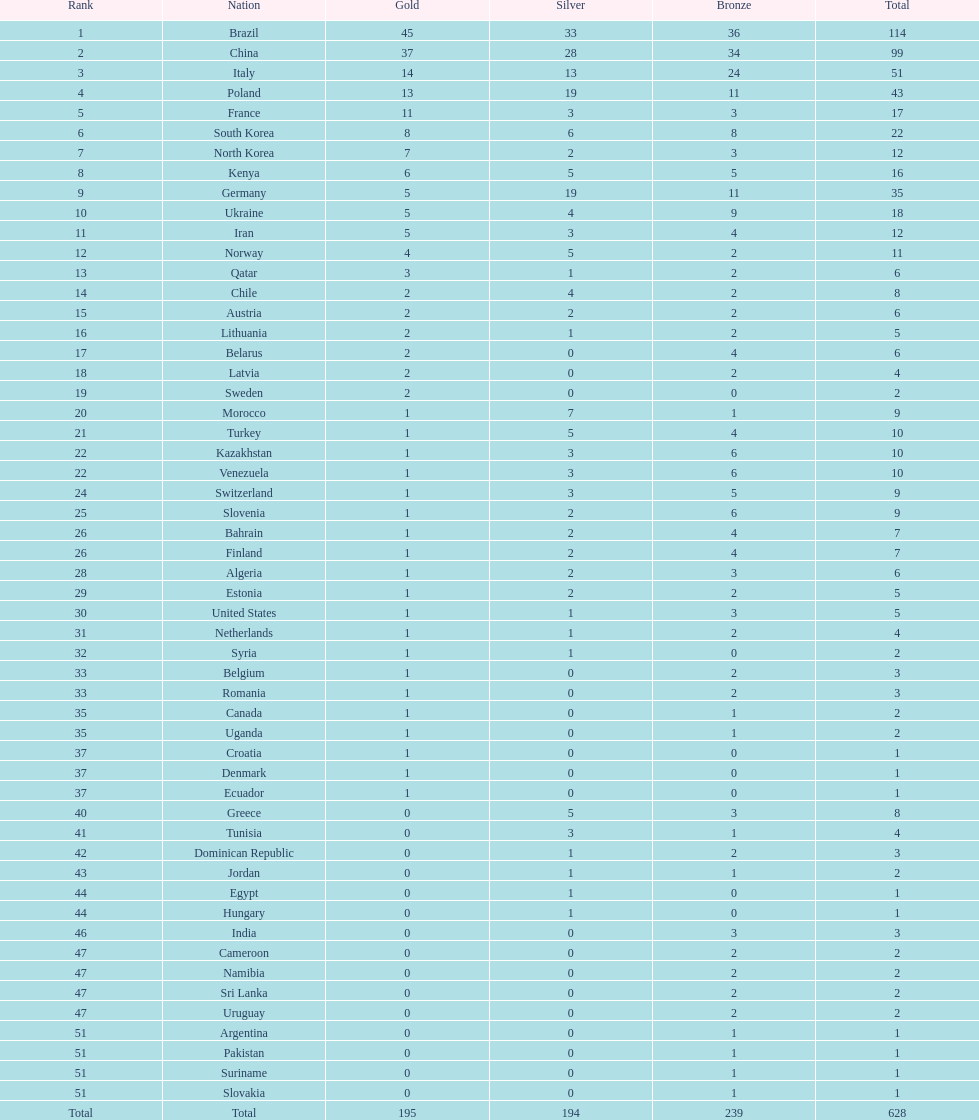What's the total count of gold medals secured by germany? 5. Can you give me this table as a dict? {'header': ['Rank', 'Nation', 'Gold', 'Silver', 'Bronze', 'Total'], 'rows': [['1', 'Brazil', '45', '33', '36', '114'], ['2', 'China', '37', '28', '34', '99'], ['3', 'Italy', '14', '13', '24', '51'], ['4', 'Poland', '13', '19', '11', '43'], ['5', 'France', '11', '3', '3', '17'], ['6', 'South Korea', '8', '6', '8', '22'], ['7', 'North Korea', '7', '2', '3', '12'], ['8', 'Kenya', '6', '5', '5', '16'], ['9', 'Germany', '5', '19', '11', '35'], ['10', 'Ukraine', '5', '4', '9', '18'], ['11', 'Iran', '5', '3', '4', '12'], ['12', 'Norway', '4', '5', '2', '11'], ['13', 'Qatar', '3', '1', '2', '6'], ['14', 'Chile', '2', '4', '2', '8'], ['15', 'Austria', '2', '2', '2', '6'], ['16', 'Lithuania', '2', '1', '2', '5'], ['17', 'Belarus', '2', '0', '4', '6'], ['18', 'Latvia', '2', '0', '2', '4'], ['19', 'Sweden', '2', '0', '0', '2'], ['20', 'Morocco', '1', '7', '1', '9'], ['21', 'Turkey', '1', '5', '4', '10'], ['22', 'Kazakhstan', '1', '3', '6', '10'], ['22', 'Venezuela', '1', '3', '6', '10'], ['24', 'Switzerland', '1', '3', '5', '9'], ['25', 'Slovenia', '1', '2', '6', '9'], ['26', 'Bahrain', '1', '2', '4', '7'], ['26', 'Finland', '1', '2', '4', '7'], ['28', 'Algeria', '1', '2', '3', '6'], ['29', 'Estonia', '1', '2', '2', '5'], ['30', 'United States', '1', '1', '3', '5'], ['31', 'Netherlands', '1', '1', '2', '4'], ['32', 'Syria', '1', '1', '0', '2'], ['33', 'Belgium', '1', '0', '2', '3'], ['33', 'Romania', '1', '0', '2', '3'], ['35', 'Canada', '1', '0', '1', '2'], ['35', 'Uganda', '1', '0', '1', '2'], ['37', 'Croatia', '1', '0', '0', '1'], ['37', 'Denmark', '1', '0', '0', '1'], ['37', 'Ecuador', '1', '0', '0', '1'], ['40', 'Greece', '0', '5', '3', '8'], ['41', 'Tunisia', '0', '3', '1', '4'], ['42', 'Dominican Republic', '0', '1', '2', '3'], ['43', 'Jordan', '0', '1', '1', '2'], ['44', 'Egypt', '0', '1', '0', '1'], ['44', 'Hungary', '0', '1', '0', '1'], ['46', 'India', '0', '0', '3', '3'], ['47', 'Cameroon', '0', '0', '2', '2'], ['47', 'Namibia', '0', '0', '2', '2'], ['47', 'Sri Lanka', '0', '0', '2', '2'], ['47', 'Uruguay', '0', '0', '2', '2'], ['51', 'Argentina', '0', '0', '1', '1'], ['51', 'Pakistan', '0', '0', '1', '1'], ['51', 'Suriname', '0', '0', '1', '1'], ['51', 'Slovakia', '0', '0', '1', '1'], ['Total', 'Total', '195', '194', '239', '628']]} 